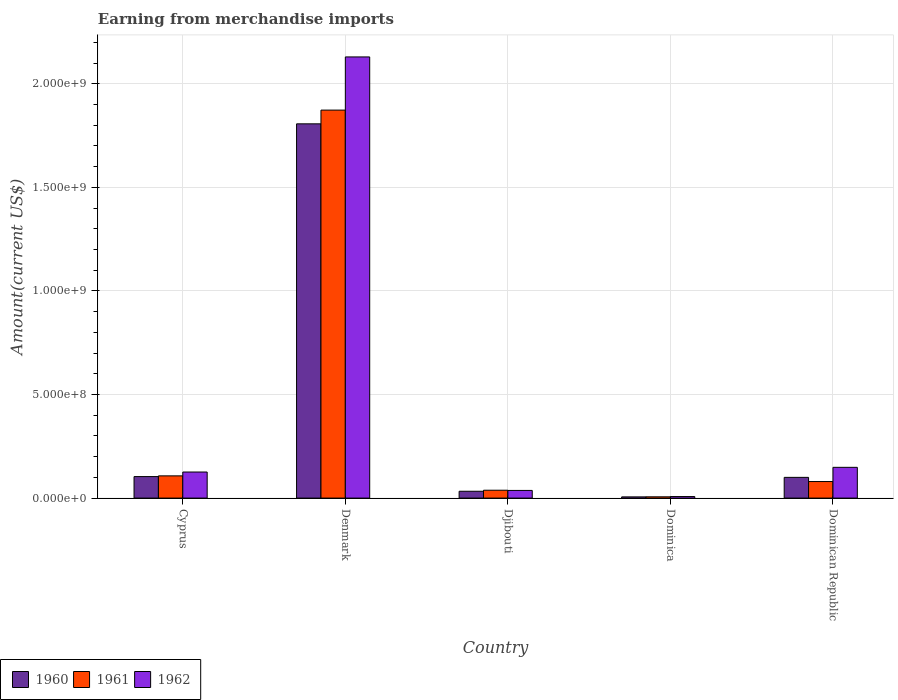How many different coloured bars are there?
Offer a terse response. 3. In how many cases, is the number of bars for a given country not equal to the number of legend labels?
Offer a very short reply. 0. What is the amount earned from merchandise imports in 1960 in Dominican Republic?
Your answer should be very brief. 1.00e+08. Across all countries, what is the maximum amount earned from merchandise imports in 1962?
Offer a very short reply. 2.13e+09. Across all countries, what is the minimum amount earned from merchandise imports in 1960?
Keep it short and to the point. 5.81e+06. In which country was the amount earned from merchandise imports in 1960 minimum?
Give a very brief answer. Dominica. What is the total amount earned from merchandise imports in 1961 in the graph?
Offer a very short reply. 2.10e+09. What is the difference between the amount earned from merchandise imports in 1960 in Denmark and that in Dominica?
Give a very brief answer. 1.80e+09. What is the difference between the amount earned from merchandise imports in 1962 in Djibouti and the amount earned from merchandise imports in 1961 in Dominica?
Keep it short and to the point. 3.08e+07. What is the average amount earned from merchandise imports in 1960 per country?
Give a very brief answer. 4.10e+08. What is the difference between the amount earned from merchandise imports of/in 1962 and amount earned from merchandise imports of/in 1961 in Dominica?
Your answer should be compact. 1.24e+06. What is the ratio of the amount earned from merchandise imports in 1961 in Denmark to that in Dominica?
Give a very brief answer. 303.62. Is the difference between the amount earned from merchandise imports in 1962 in Djibouti and Dominica greater than the difference between the amount earned from merchandise imports in 1961 in Djibouti and Dominica?
Your answer should be compact. No. What is the difference between the highest and the second highest amount earned from merchandise imports in 1962?
Make the answer very short. 1.98e+09. What is the difference between the highest and the lowest amount earned from merchandise imports in 1961?
Make the answer very short. 1.87e+09. What does the 2nd bar from the right in Dominican Republic represents?
Offer a very short reply. 1961. Is it the case that in every country, the sum of the amount earned from merchandise imports in 1962 and amount earned from merchandise imports in 1960 is greater than the amount earned from merchandise imports in 1961?
Make the answer very short. Yes. How many bars are there?
Keep it short and to the point. 15. Does the graph contain grids?
Your answer should be very brief. Yes. How are the legend labels stacked?
Keep it short and to the point. Horizontal. What is the title of the graph?
Provide a succinct answer. Earning from merchandise imports. Does "1968" appear as one of the legend labels in the graph?
Make the answer very short. No. What is the label or title of the X-axis?
Provide a short and direct response. Country. What is the label or title of the Y-axis?
Give a very brief answer. Amount(current US$). What is the Amount(current US$) of 1960 in Cyprus?
Make the answer very short. 1.04e+08. What is the Amount(current US$) of 1961 in Cyprus?
Offer a terse response. 1.07e+08. What is the Amount(current US$) in 1962 in Cyprus?
Offer a very short reply. 1.26e+08. What is the Amount(current US$) in 1960 in Denmark?
Ensure brevity in your answer.  1.81e+09. What is the Amount(current US$) in 1961 in Denmark?
Keep it short and to the point. 1.87e+09. What is the Amount(current US$) of 1962 in Denmark?
Your response must be concise. 2.13e+09. What is the Amount(current US$) in 1960 in Djibouti?
Your answer should be very brief. 3.30e+07. What is the Amount(current US$) in 1961 in Djibouti?
Keep it short and to the point. 3.80e+07. What is the Amount(current US$) in 1962 in Djibouti?
Provide a succinct answer. 3.70e+07. What is the Amount(current US$) in 1960 in Dominica?
Your answer should be compact. 5.81e+06. What is the Amount(current US$) in 1961 in Dominica?
Your answer should be very brief. 6.17e+06. What is the Amount(current US$) of 1962 in Dominica?
Provide a succinct answer. 7.41e+06. What is the Amount(current US$) in 1960 in Dominican Republic?
Offer a very short reply. 1.00e+08. What is the Amount(current US$) in 1961 in Dominican Republic?
Your answer should be very brief. 7.99e+07. What is the Amount(current US$) of 1962 in Dominican Republic?
Your response must be concise. 1.48e+08. Across all countries, what is the maximum Amount(current US$) in 1960?
Your response must be concise. 1.81e+09. Across all countries, what is the maximum Amount(current US$) of 1961?
Keep it short and to the point. 1.87e+09. Across all countries, what is the maximum Amount(current US$) in 1962?
Ensure brevity in your answer.  2.13e+09. Across all countries, what is the minimum Amount(current US$) in 1960?
Your answer should be very brief. 5.81e+06. Across all countries, what is the minimum Amount(current US$) of 1961?
Provide a short and direct response. 6.17e+06. Across all countries, what is the minimum Amount(current US$) in 1962?
Your answer should be compact. 7.41e+06. What is the total Amount(current US$) in 1960 in the graph?
Offer a terse response. 2.05e+09. What is the total Amount(current US$) in 1961 in the graph?
Provide a succinct answer. 2.10e+09. What is the total Amount(current US$) in 1962 in the graph?
Make the answer very short. 2.45e+09. What is the difference between the Amount(current US$) of 1960 in Cyprus and that in Denmark?
Make the answer very short. -1.70e+09. What is the difference between the Amount(current US$) in 1961 in Cyprus and that in Denmark?
Offer a terse response. -1.77e+09. What is the difference between the Amount(current US$) of 1962 in Cyprus and that in Denmark?
Offer a terse response. -2.00e+09. What is the difference between the Amount(current US$) of 1960 in Cyprus and that in Djibouti?
Keep it short and to the point. 7.08e+07. What is the difference between the Amount(current US$) in 1961 in Cyprus and that in Djibouti?
Keep it short and to the point. 6.93e+07. What is the difference between the Amount(current US$) in 1962 in Cyprus and that in Djibouti?
Your answer should be compact. 8.89e+07. What is the difference between the Amount(current US$) in 1960 in Cyprus and that in Dominica?
Your answer should be compact. 9.80e+07. What is the difference between the Amount(current US$) of 1961 in Cyprus and that in Dominica?
Your answer should be very brief. 1.01e+08. What is the difference between the Amount(current US$) of 1962 in Cyprus and that in Dominica?
Your answer should be very brief. 1.18e+08. What is the difference between the Amount(current US$) of 1960 in Cyprus and that in Dominican Republic?
Make the answer very short. 3.76e+06. What is the difference between the Amount(current US$) in 1961 in Cyprus and that in Dominican Republic?
Make the answer very short. 2.74e+07. What is the difference between the Amount(current US$) in 1962 in Cyprus and that in Dominican Republic?
Offer a very short reply. -2.26e+07. What is the difference between the Amount(current US$) of 1960 in Denmark and that in Djibouti?
Offer a very short reply. 1.77e+09. What is the difference between the Amount(current US$) in 1961 in Denmark and that in Djibouti?
Offer a terse response. 1.84e+09. What is the difference between the Amount(current US$) in 1962 in Denmark and that in Djibouti?
Ensure brevity in your answer.  2.09e+09. What is the difference between the Amount(current US$) of 1960 in Denmark and that in Dominica?
Your answer should be very brief. 1.80e+09. What is the difference between the Amount(current US$) in 1961 in Denmark and that in Dominica?
Your response must be concise. 1.87e+09. What is the difference between the Amount(current US$) in 1962 in Denmark and that in Dominica?
Give a very brief answer. 2.12e+09. What is the difference between the Amount(current US$) of 1960 in Denmark and that in Dominican Republic?
Ensure brevity in your answer.  1.71e+09. What is the difference between the Amount(current US$) in 1961 in Denmark and that in Dominican Republic?
Keep it short and to the point. 1.79e+09. What is the difference between the Amount(current US$) of 1962 in Denmark and that in Dominican Republic?
Your response must be concise. 1.98e+09. What is the difference between the Amount(current US$) of 1960 in Djibouti and that in Dominica?
Give a very brief answer. 2.72e+07. What is the difference between the Amount(current US$) in 1961 in Djibouti and that in Dominica?
Offer a very short reply. 3.18e+07. What is the difference between the Amount(current US$) in 1962 in Djibouti and that in Dominica?
Make the answer very short. 2.96e+07. What is the difference between the Amount(current US$) of 1960 in Djibouti and that in Dominican Republic?
Your response must be concise. -6.70e+07. What is the difference between the Amount(current US$) of 1961 in Djibouti and that in Dominican Republic?
Your response must be concise. -4.19e+07. What is the difference between the Amount(current US$) in 1962 in Djibouti and that in Dominican Republic?
Make the answer very short. -1.11e+08. What is the difference between the Amount(current US$) of 1960 in Dominica and that in Dominican Republic?
Offer a terse response. -9.42e+07. What is the difference between the Amount(current US$) in 1961 in Dominica and that in Dominican Republic?
Your answer should be very brief. -7.38e+07. What is the difference between the Amount(current US$) of 1962 in Dominica and that in Dominican Republic?
Your answer should be very brief. -1.41e+08. What is the difference between the Amount(current US$) of 1960 in Cyprus and the Amount(current US$) of 1961 in Denmark?
Keep it short and to the point. -1.77e+09. What is the difference between the Amount(current US$) of 1960 in Cyprus and the Amount(current US$) of 1962 in Denmark?
Offer a very short reply. -2.03e+09. What is the difference between the Amount(current US$) of 1961 in Cyprus and the Amount(current US$) of 1962 in Denmark?
Ensure brevity in your answer.  -2.02e+09. What is the difference between the Amount(current US$) in 1960 in Cyprus and the Amount(current US$) in 1961 in Djibouti?
Provide a short and direct response. 6.58e+07. What is the difference between the Amount(current US$) in 1960 in Cyprus and the Amount(current US$) in 1962 in Djibouti?
Your answer should be very brief. 6.68e+07. What is the difference between the Amount(current US$) of 1961 in Cyprus and the Amount(current US$) of 1962 in Djibouti?
Keep it short and to the point. 7.03e+07. What is the difference between the Amount(current US$) in 1960 in Cyprus and the Amount(current US$) in 1961 in Dominica?
Provide a succinct answer. 9.76e+07. What is the difference between the Amount(current US$) of 1960 in Cyprus and the Amount(current US$) of 1962 in Dominica?
Make the answer very short. 9.64e+07. What is the difference between the Amount(current US$) in 1961 in Cyprus and the Amount(current US$) in 1962 in Dominica?
Your response must be concise. 9.99e+07. What is the difference between the Amount(current US$) of 1960 in Cyprus and the Amount(current US$) of 1961 in Dominican Republic?
Give a very brief answer. 2.39e+07. What is the difference between the Amount(current US$) of 1960 in Cyprus and the Amount(current US$) of 1962 in Dominican Republic?
Offer a very short reply. -4.47e+07. What is the difference between the Amount(current US$) in 1961 in Cyprus and the Amount(current US$) in 1962 in Dominican Republic?
Ensure brevity in your answer.  -4.11e+07. What is the difference between the Amount(current US$) of 1960 in Denmark and the Amount(current US$) of 1961 in Djibouti?
Your answer should be very brief. 1.77e+09. What is the difference between the Amount(current US$) of 1960 in Denmark and the Amount(current US$) of 1962 in Djibouti?
Offer a terse response. 1.77e+09. What is the difference between the Amount(current US$) in 1961 in Denmark and the Amount(current US$) in 1962 in Djibouti?
Provide a short and direct response. 1.84e+09. What is the difference between the Amount(current US$) in 1960 in Denmark and the Amount(current US$) in 1961 in Dominica?
Provide a succinct answer. 1.80e+09. What is the difference between the Amount(current US$) of 1960 in Denmark and the Amount(current US$) of 1962 in Dominica?
Your answer should be compact. 1.80e+09. What is the difference between the Amount(current US$) of 1961 in Denmark and the Amount(current US$) of 1962 in Dominica?
Make the answer very short. 1.87e+09. What is the difference between the Amount(current US$) in 1960 in Denmark and the Amount(current US$) in 1961 in Dominican Republic?
Make the answer very short. 1.73e+09. What is the difference between the Amount(current US$) in 1960 in Denmark and the Amount(current US$) in 1962 in Dominican Republic?
Make the answer very short. 1.66e+09. What is the difference between the Amount(current US$) of 1961 in Denmark and the Amount(current US$) of 1962 in Dominican Republic?
Your answer should be very brief. 1.72e+09. What is the difference between the Amount(current US$) of 1960 in Djibouti and the Amount(current US$) of 1961 in Dominica?
Provide a short and direct response. 2.68e+07. What is the difference between the Amount(current US$) in 1960 in Djibouti and the Amount(current US$) in 1962 in Dominica?
Ensure brevity in your answer.  2.56e+07. What is the difference between the Amount(current US$) in 1961 in Djibouti and the Amount(current US$) in 1962 in Dominica?
Your answer should be compact. 3.06e+07. What is the difference between the Amount(current US$) in 1960 in Djibouti and the Amount(current US$) in 1961 in Dominican Republic?
Keep it short and to the point. -4.69e+07. What is the difference between the Amount(current US$) in 1960 in Djibouti and the Amount(current US$) in 1962 in Dominican Republic?
Give a very brief answer. -1.15e+08. What is the difference between the Amount(current US$) of 1961 in Djibouti and the Amount(current US$) of 1962 in Dominican Republic?
Keep it short and to the point. -1.10e+08. What is the difference between the Amount(current US$) of 1960 in Dominica and the Amount(current US$) of 1961 in Dominican Republic?
Ensure brevity in your answer.  -7.41e+07. What is the difference between the Amount(current US$) of 1960 in Dominica and the Amount(current US$) of 1962 in Dominican Republic?
Your response must be concise. -1.43e+08. What is the difference between the Amount(current US$) in 1961 in Dominica and the Amount(current US$) in 1962 in Dominican Republic?
Your answer should be very brief. -1.42e+08. What is the average Amount(current US$) in 1960 per country?
Offer a very short reply. 4.10e+08. What is the average Amount(current US$) in 1961 per country?
Give a very brief answer. 4.21e+08. What is the average Amount(current US$) in 1962 per country?
Make the answer very short. 4.90e+08. What is the difference between the Amount(current US$) of 1960 and Amount(current US$) of 1961 in Cyprus?
Provide a short and direct response. -3.52e+06. What is the difference between the Amount(current US$) in 1960 and Amount(current US$) in 1962 in Cyprus?
Provide a succinct answer. -2.21e+07. What is the difference between the Amount(current US$) of 1961 and Amount(current US$) of 1962 in Cyprus?
Your answer should be very brief. -1.85e+07. What is the difference between the Amount(current US$) in 1960 and Amount(current US$) in 1961 in Denmark?
Ensure brevity in your answer.  -6.63e+07. What is the difference between the Amount(current US$) in 1960 and Amount(current US$) in 1962 in Denmark?
Give a very brief answer. -3.23e+08. What is the difference between the Amount(current US$) in 1961 and Amount(current US$) in 1962 in Denmark?
Your answer should be compact. -2.57e+08. What is the difference between the Amount(current US$) of 1960 and Amount(current US$) of 1961 in Djibouti?
Provide a short and direct response. -5.00e+06. What is the difference between the Amount(current US$) of 1961 and Amount(current US$) of 1962 in Djibouti?
Your answer should be very brief. 1.00e+06. What is the difference between the Amount(current US$) of 1960 and Amount(current US$) of 1961 in Dominica?
Your response must be concise. -3.58e+05. What is the difference between the Amount(current US$) in 1960 and Amount(current US$) in 1962 in Dominica?
Your answer should be compact. -1.60e+06. What is the difference between the Amount(current US$) of 1961 and Amount(current US$) of 1962 in Dominica?
Offer a very short reply. -1.24e+06. What is the difference between the Amount(current US$) in 1960 and Amount(current US$) in 1961 in Dominican Republic?
Your answer should be compact. 2.01e+07. What is the difference between the Amount(current US$) in 1960 and Amount(current US$) in 1962 in Dominican Republic?
Your answer should be compact. -4.84e+07. What is the difference between the Amount(current US$) of 1961 and Amount(current US$) of 1962 in Dominican Republic?
Make the answer very short. -6.85e+07. What is the ratio of the Amount(current US$) in 1960 in Cyprus to that in Denmark?
Offer a very short reply. 0.06. What is the ratio of the Amount(current US$) of 1961 in Cyprus to that in Denmark?
Give a very brief answer. 0.06. What is the ratio of the Amount(current US$) of 1962 in Cyprus to that in Denmark?
Offer a terse response. 0.06. What is the ratio of the Amount(current US$) of 1960 in Cyprus to that in Djibouti?
Offer a very short reply. 3.15. What is the ratio of the Amount(current US$) in 1961 in Cyprus to that in Djibouti?
Provide a short and direct response. 2.82. What is the ratio of the Amount(current US$) in 1962 in Cyprus to that in Djibouti?
Provide a succinct answer. 3.4. What is the ratio of the Amount(current US$) of 1960 in Cyprus to that in Dominica?
Your response must be concise. 17.86. What is the ratio of the Amount(current US$) in 1961 in Cyprus to that in Dominica?
Give a very brief answer. 17.4. What is the ratio of the Amount(current US$) of 1962 in Cyprus to that in Dominica?
Give a very brief answer. 16.98. What is the ratio of the Amount(current US$) of 1960 in Cyprus to that in Dominican Republic?
Give a very brief answer. 1.04. What is the ratio of the Amount(current US$) in 1961 in Cyprus to that in Dominican Republic?
Provide a succinct answer. 1.34. What is the ratio of the Amount(current US$) in 1962 in Cyprus to that in Dominican Republic?
Ensure brevity in your answer.  0.85. What is the ratio of the Amount(current US$) of 1960 in Denmark to that in Djibouti?
Give a very brief answer. 54.76. What is the ratio of the Amount(current US$) in 1961 in Denmark to that in Djibouti?
Offer a terse response. 49.3. What is the ratio of the Amount(current US$) of 1962 in Denmark to that in Djibouti?
Offer a very short reply. 57.57. What is the ratio of the Amount(current US$) in 1960 in Denmark to that in Dominica?
Offer a terse response. 310.89. What is the ratio of the Amount(current US$) in 1961 in Denmark to that in Dominica?
Ensure brevity in your answer.  303.62. What is the ratio of the Amount(current US$) of 1962 in Denmark to that in Dominica?
Provide a succinct answer. 287.33. What is the ratio of the Amount(current US$) of 1960 in Denmark to that in Dominican Republic?
Your answer should be very brief. 18.06. What is the ratio of the Amount(current US$) in 1961 in Denmark to that in Dominican Republic?
Your answer should be compact. 23.44. What is the ratio of the Amount(current US$) of 1962 in Denmark to that in Dominican Republic?
Your answer should be compact. 14.35. What is the ratio of the Amount(current US$) of 1960 in Djibouti to that in Dominica?
Provide a short and direct response. 5.68. What is the ratio of the Amount(current US$) in 1961 in Djibouti to that in Dominica?
Make the answer very short. 6.16. What is the ratio of the Amount(current US$) in 1962 in Djibouti to that in Dominica?
Your answer should be very brief. 4.99. What is the ratio of the Amount(current US$) in 1960 in Djibouti to that in Dominican Republic?
Give a very brief answer. 0.33. What is the ratio of the Amount(current US$) of 1961 in Djibouti to that in Dominican Republic?
Your answer should be compact. 0.48. What is the ratio of the Amount(current US$) in 1962 in Djibouti to that in Dominican Republic?
Your answer should be compact. 0.25. What is the ratio of the Amount(current US$) of 1960 in Dominica to that in Dominican Republic?
Offer a very short reply. 0.06. What is the ratio of the Amount(current US$) of 1961 in Dominica to that in Dominican Republic?
Your response must be concise. 0.08. What is the ratio of the Amount(current US$) of 1962 in Dominica to that in Dominican Republic?
Ensure brevity in your answer.  0.05. What is the difference between the highest and the second highest Amount(current US$) in 1960?
Offer a terse response. 1.70e+09. What is the difference between the highest and the second highest Amount(current US$) in 1961?
Your answer should be very brief. 1.77e+09. What is the difference between the highest and the second highest Amount(current US$) in 1962?
Your answer should be very brief. 1.98e+09. What is the difference between the highest and the lowest Amount(current US$) of 1960?
Provide a succinct answer. 1.80e+09. What is the difference between the highest and the lowest Amount(current US$) of 1961?
Your answer should be very brief. 1.87e+09. What is the difference between the highest and the lowest Amount(current US$) of 1962?
Keep it short and to the point. 2.12e+09. 